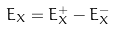<formula> <loc_0><loc_0><loc_500><loc_500>E _ { X } = E ^ { + } _ { X } - E ^ { - } _ { X }</formula> 